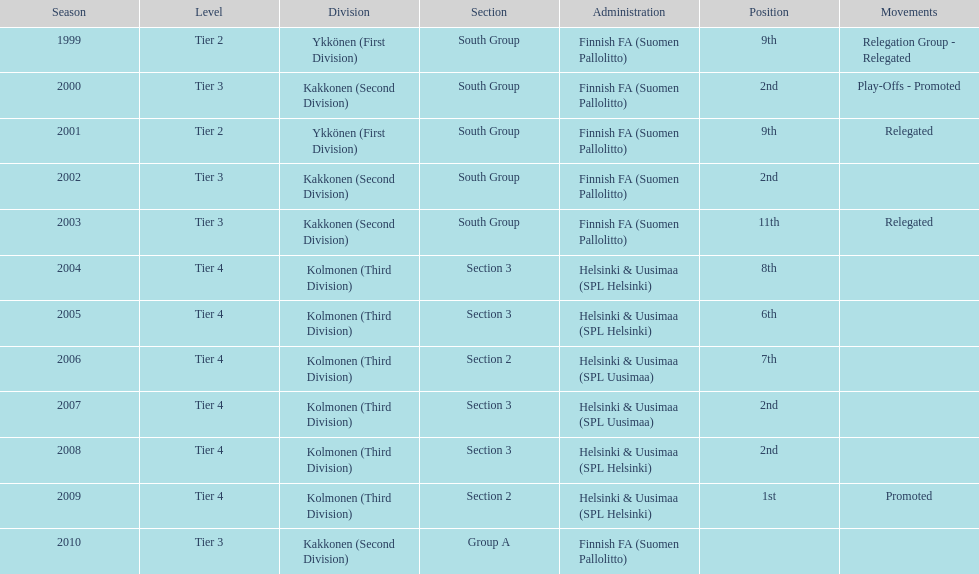How many 2nd positions were there? 4. 